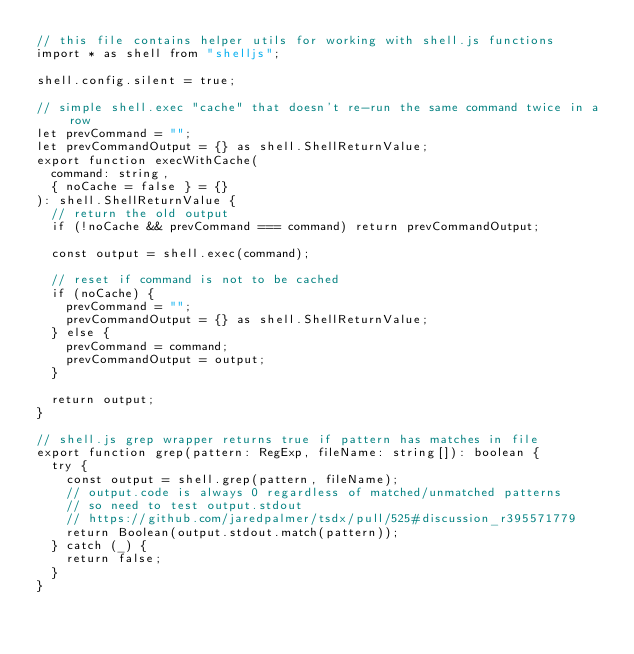Convert code to text. <code><loc_0><loc_0><loc_500><loc_500><_TypeScript_>// this file contains helper utils for working with shell.js functions
import * as shell from "shelljs";

shell.config.silent = true;

// simple shell.exec "cache" that doesn't re-run the same command twice in a row
let prevCommand = "";
let prevCommandOutput = {} as shell.ShellReturnValue;
export function execWithCache(
	command: string,
	{ noCache = false } = {}
): shell.ShellReturnValue {
	// return the old output
	if (!noCache && prevCommand === command) return prevCommandOutput;

	const output = shell.exec(command);

	// reset if command is not to be cached
	if (noCache) {
		prevCommand = "";
		prevCommandOutput = {} as shell.ShellReturnValue;
	} else {
		prevCommand = command;
		prevCommandOutput = output;
	}

	return output;
}

// shell.js grep wrapper returns true if pattern has matches in file
export function grep(pattern: RegExp, fileName: string[]): boolean {
	try {
		const output = shell.grep(pattern, fileName);
		// output.code is always 0 regardless of matched/unmatched patterns
		// so need to test output.stdout
		// https://github.com/jaredpalmer/tsdx/pull/525#discussion_r395571779
		return Boolean(output.stdout.match(pattern));
	} catch (_) {
		return false;
	}
}
</code> 